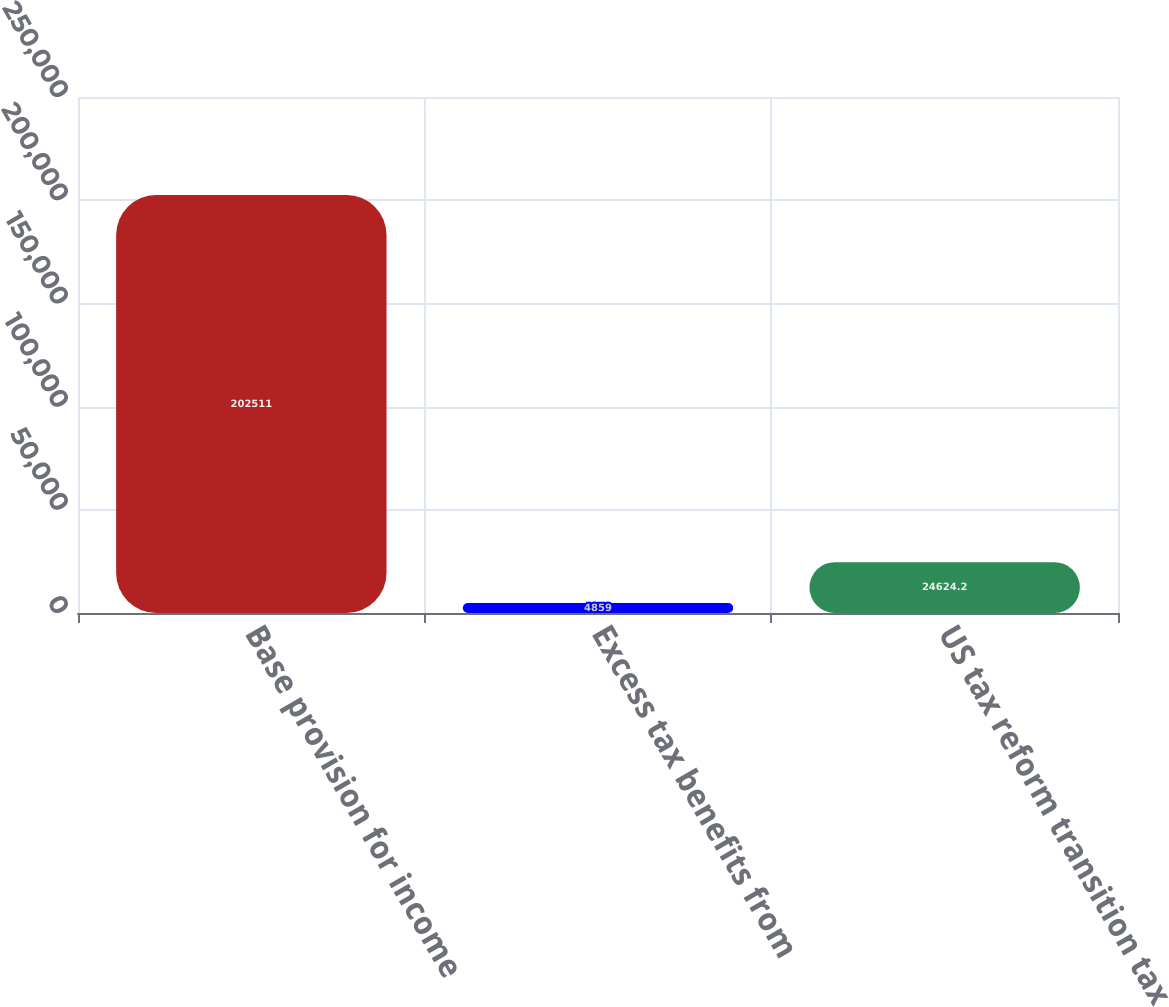Convert chart to OTSL. <chart><loc_0><loc_0><loc_500><loc_500><bar_chart><fcel>Base provision for income<fcel>Excess tax benefits from<fcel>US tax reform transition tax<nl><fcel>202511<fcel>4859<fcel>24624.2<nl></chart> 